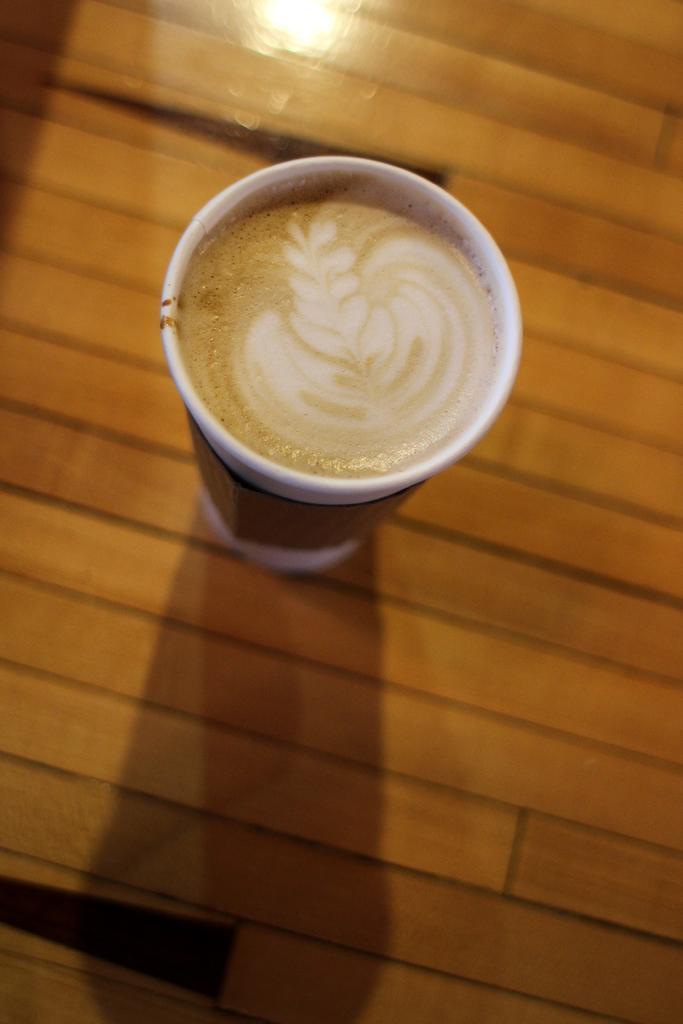Could you give a brief overview of what you see in this image? In this image there is a coffee cup on the table. 